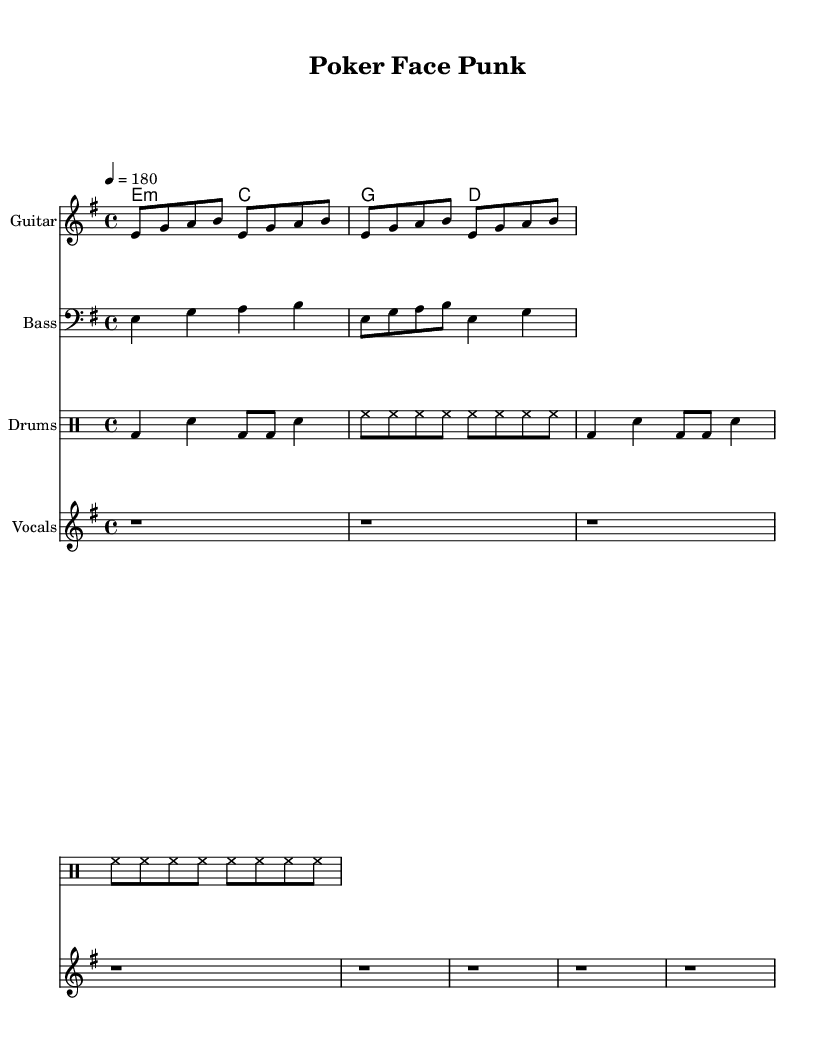What is the key signature of this music? The key signature is E minor, which contains one sharp (F#). This can be identified in the first part of the music notation where the key signature is indicated.
Answer: E minor What is the time signature of this music? The time signature is 4/4, which is indicated at the beginning of the music. This means there are four beats per measure, and the quarter note gets one beat.
Answer: 4/4 What is the tempo marking of this music? The tempo marking is indicated as quarter note equals 180 beats per minute. This tells us how fast the music should be played. It's located in the first part of the score.
Answer: 180 How many measures are in the chorus? The chorus is structured in two measures, as shown in the music where the chorus chords are presented. Each chord represents a measure, and there are two distinct lines.
Answer: 2 What are the main themes expressed in the verse lyrics? The verse lyrics focus on themes of bluffing and confidence, emphasizing the strategic aspect of poker combined with a sense of style. This is derived from the lyrics listed below the melody that portray a strong image.
Answer: Bluffing and confidence What type of musical instrument is used for the drum pattern? The drum pattern is specifically written for a drum set, as indicated by the mode used in the notation (drummode), which outlines the beats played by drums.
Answer: Drum set How does the tempo contribute to the overall energy of the punk style of the piece? The fast tempo of 180 BPM contributes to the high energy typical of punk music genre, setting an aggressive and lively atmosphere that matches the themes of strategic bluffing and confidence in poker.
Answer: High energy 